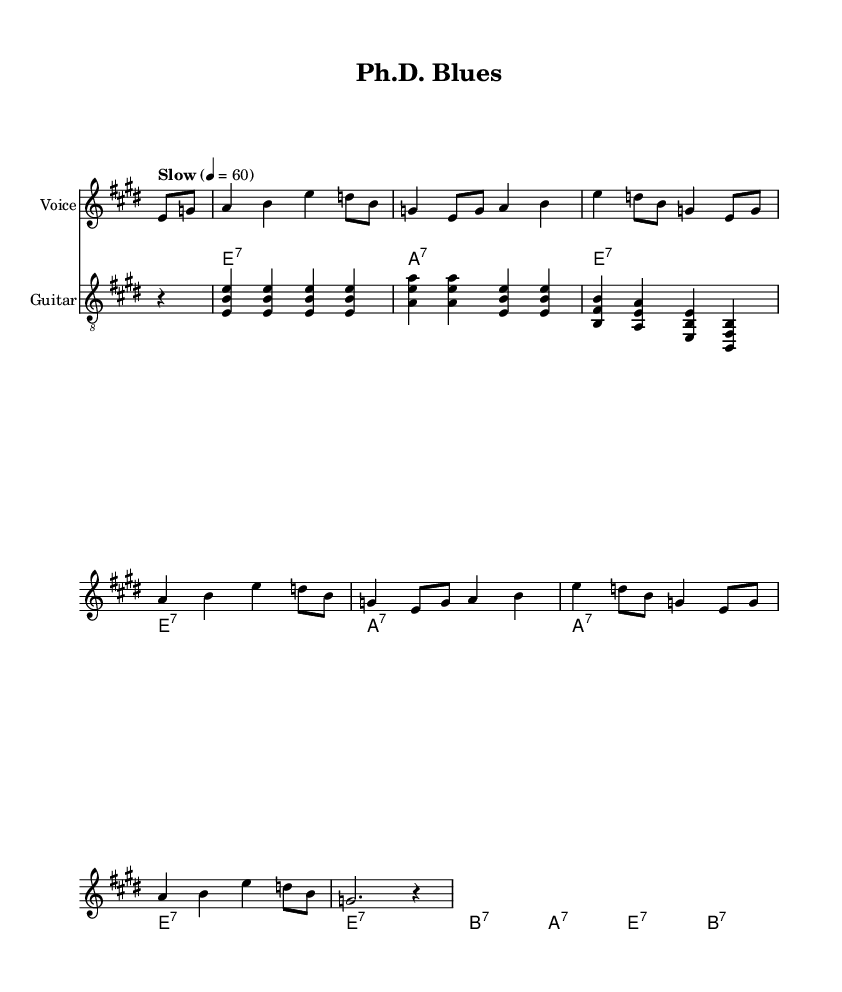What is the key signature of this music? The key signature appears before the notes and indicates E major, which has four sharps (F#, C#, G#, D#).
Answer: E major What is the time signature of this music? The time signature is located at the beginning of the staff and shows 4/4, indicating four beats per measure with a quarter note receiving one beat.
Answer: 4/4 What is the tempo marking of this music? The tempo marking is indicated at the beginning of the score, stating "Slow" with a metronome marking of 60 beats per minute.
Answer: Slow How many measures are in the verse section? By counting the notations in the verse part, there are eight measures present.
Answer: Eight Which chords are played during the chorus? The chord symbols are listed above the staff in the chord names section, specifically showing E7, A7, and B7 during the chorus.
Answer: E7, A7, B7 What unique musical feature identifies this piece as a Blues? The structure and lyrical themes emphasize the use of a 12-bar format along with specific chord progressions typical of the blues genre, focusing on emotional struggles.
Answer: 12-bar format What specific emotional theme is reflected in the lyrics? The lyrics express struggles related to academic life, discussing issues like stress from complex systems and the burdens of a Ph.D. program.
Answer: Academic struggles 